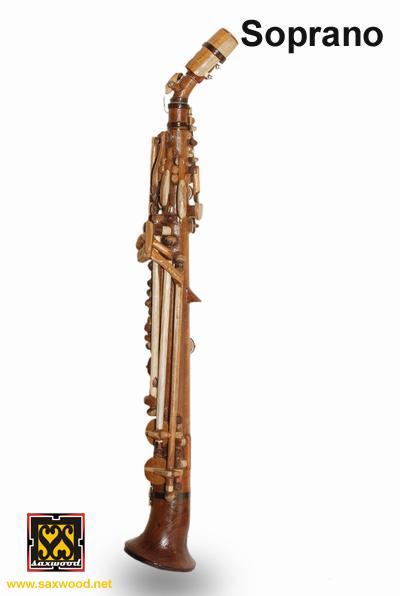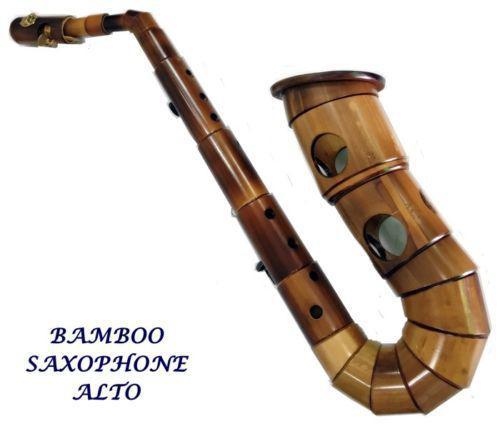The first image is the image on the left, the second image is the image on the right. Assess this claim about the two images: "One of the images contains at least two saxophones.". Correct or not? Answer yes or no. No. 